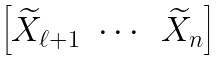Convert formula to latex. <formula><loc_0><loc_0><loc_500><loc_500>\begin{bmatrix} \widetilde { X } _ { \ell + 1 } & \cdots & \widetilde { X } _ { n } \end{bmatrix}</formula> 